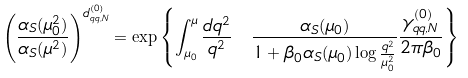<formula> <loc_0><loc_0><loc_500><loc_500>\left ( \frac { \alpha _ { S } ( \mu ^ { 2 } _ { 0 } ) } { \alpha _ { S } ( \mu ^ { 2 } ) } \right ) ^ { d _ { q q , N } ^ { ( 0 ) } } = \exp \left \{ \int _ { \mu _ { 0 } } ^ { \mu } \frac { d q ^ { 2 } } { q ^ { 2 } } \ \frac { \alpha _ { S } { ( \mu _ { 0 } ) } } { 1 + \beta _ { 0 } \alpha _ { S } ( \mu _ { 0 } ) \log { \frac { q ^ { 2 } } { \mu ^ { 2 } _ { 0 } } } } \frac { \gamma ^ { ( 0 ) } _ { q q , N } } { 2 \pi \beta _ { 0 } } \right \}</formula> 